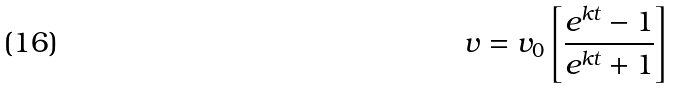<formula> <loc_0><loc_0><loc_500><loc_500>v = v _ { 0 } \left [ \frac { e ^ { k t } - 1 } { e ^ { k t } + 1 } \right ]</formula> 